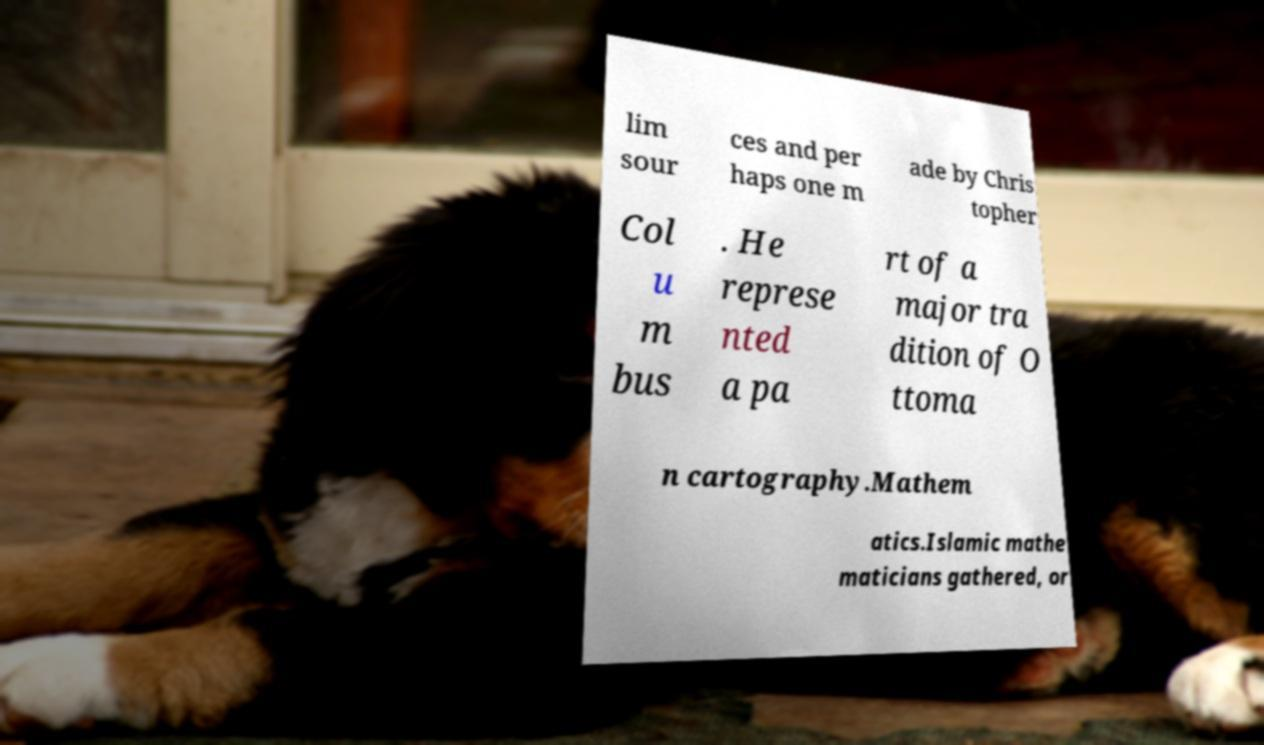Please identify and transcribe the text found in this image. lim sour ces and per haps one m ade by Chris topher Col u m bus . He represe nted a pa rt of a major tra dition of O ttoma n cartography.Mathem atics.Islamic mathe maticians gathered, or 